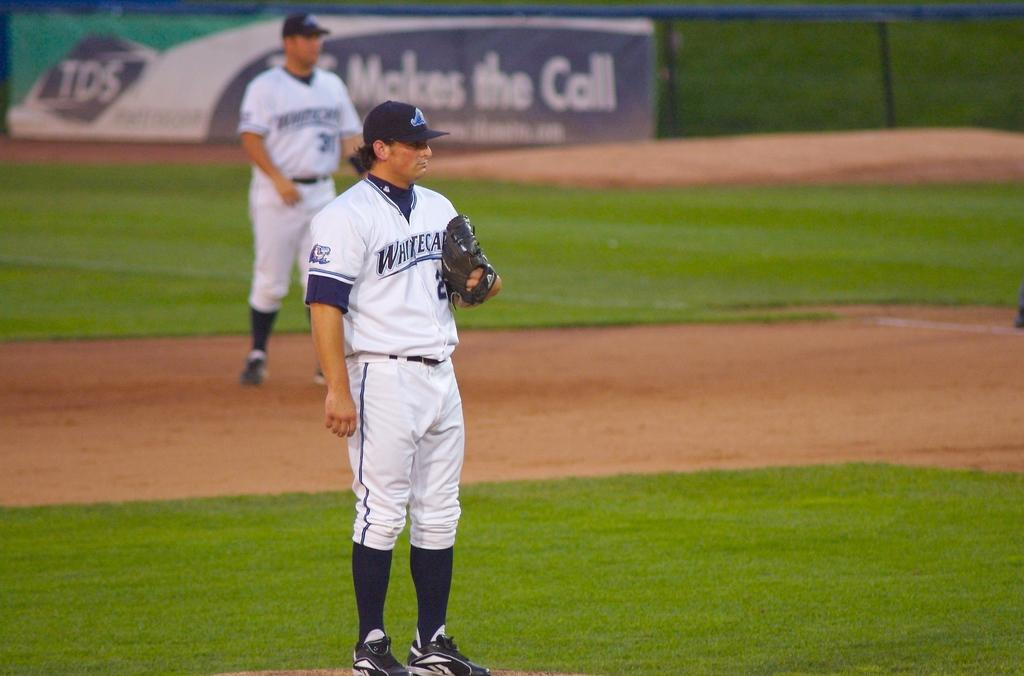<image>
Describe the image concisely. A man playing baseball for the Whitecaps is on the baseball field. 